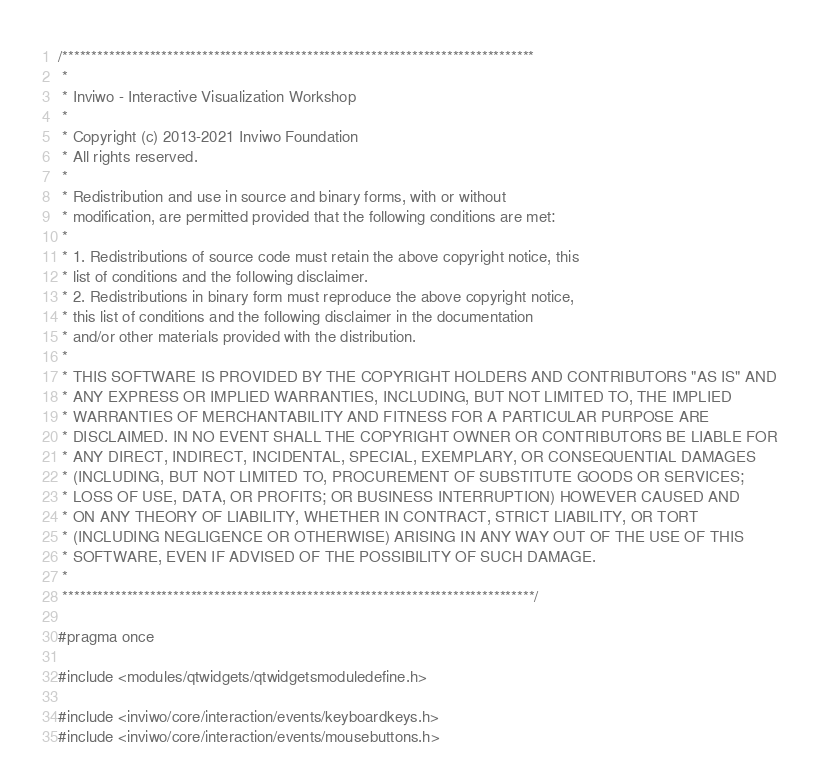Convert code to text. <code><loc_0><loc_0><loc_500><loc_500><_C_>/*********************************************************************************
 *
 * Inviwo - Interactive Visualization Workshop
 *
 * Copyright (c) 2013-2021 Inviwo Foundation
 * All rights reserved.
 *
 * Redistribution and use in source and binary forms, with or without
 * modification, are permitted provided that the following conditions are met:
 *
 * 1. Redistributions of source code must retain the above copyright notice, this
 * list of conditions and the following disclaimer.
 * 2. Redistributions in binary form must reproduce the above copyright notice,
 * this list of conditions and the following disclaimer in the documentation
 * and/or other materials provided with the distribution.
 *
 * THIS SOFTWARE IS PROVIDED BY THE COPYRIGHT HOLDERS AND CONTRIBUTORS "AS IS" AND
 * ANY EXPRESS OR IMPLIED WARRANTIES, INCLUDING, BUT NOT LIMITED TO, THE IMPLIED
 * WARRANTIES OF MERCHANTABILITY AND FITNESS FOR A PARTICULAR PURPOSE ARE
 * DISCLAIMED. IN NO EVENT SHALL THE COPYRIGHT OWNER OR CONTRIBUTORS BE LIABLE FOR
 * ANY DIRECT, INDIRECT, INCIDENTAL, SPECIAL, EXEMPLARY, OR CONSEQUENTIAL DAMAGES
 * (INCLUDING, BUT NOT LIMITED TO, PROCUREMENT OF SUBSTITUTE GOODS OR SERVICES;
 * LOSS OF USE, DATA, OR PROFITS; OR BUSINESS INTERRUPTION) HOWEVER CAUSED AND
 * ON ANY THEORY OF LIABILITY, WHETHER IN CONTRACT, STRICT LIABILITY, OR TORT
 * (INCLUDING NEGLIGENCE OR OTHERWISE) ARISING IN ANY WAY OUT OF THE USE OF THIS
 * SOFTWARE, EVEN IF ADVISED OF THE POSSIBILITY OF SUCH DAMAGE.
 *
 *********************************************************************************/

#pragma once

#include <modules/qtwidgets/qtwidgetsmoduledefine.h>

#include <inviwo/core/interaction/events/keyboardkeys.h>
#include <inviwo/core/interaction/events/mousebuttons.h></code> 